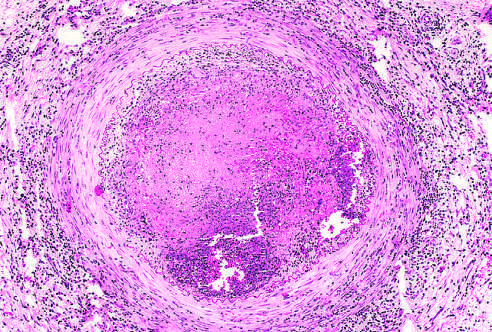s the vessel wall infiltrated with leukocytes?
Answer the question using a single word or phrase. Yes 